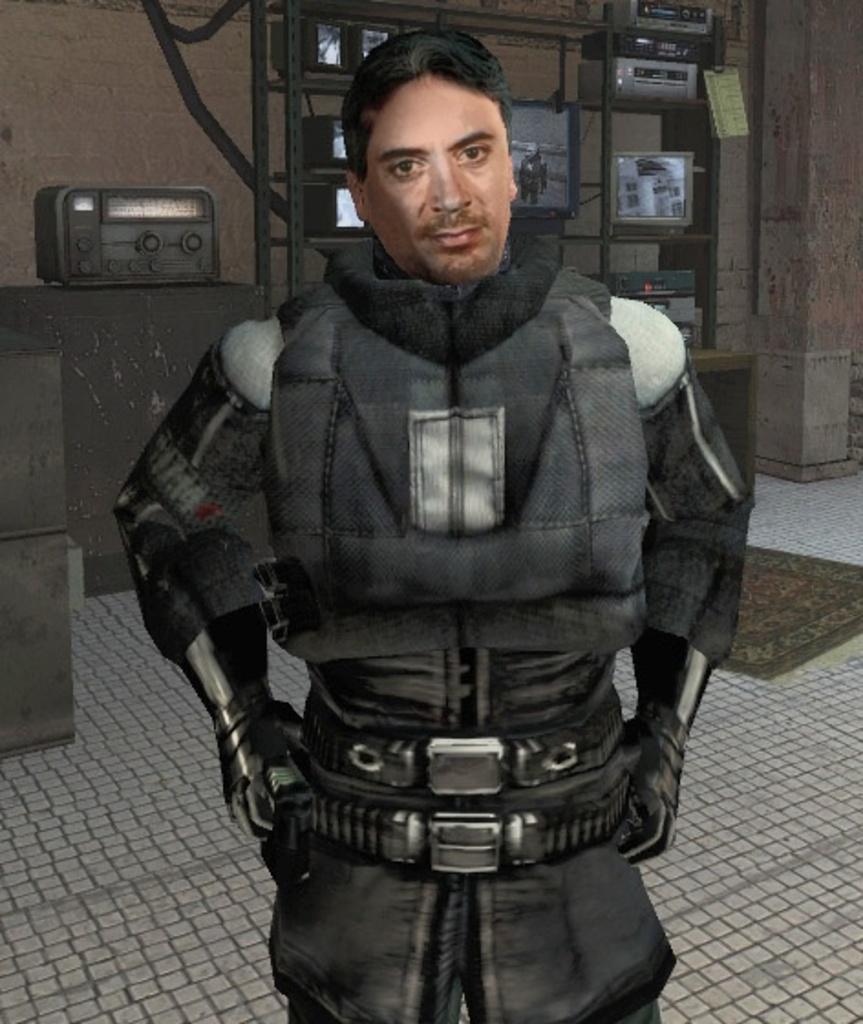Please provide a concise description of this image. In the picture we can see an edited image of a man's face to the robot structure and behind it, we can see a rack with some electronic items are placed and beside it we can see a desk with an electronic item on it. 